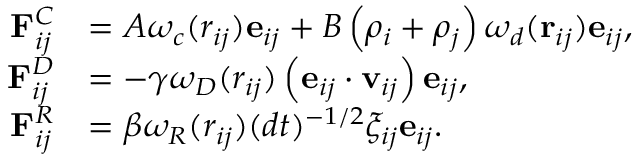Convert formula to latex. <formula><loc_0><loc_0><loc_500><loc_500>\begin{array} { r l } { F _ { i j } ^ { C } } & { = A \omega _ { c } ( r _ { i j } ) e _ { i j } + B \left ( \rho _ { i } + \rho _ { j } \right ) \omega _ { d } ( r _ { i j } ) e _ { i j } , } \\ { F _ { i j } ^ { D } } & { = - \gamma \omega _ { D } ( r _ { i j } ) \left ( e _ { i j } \cdot v _ { i j } \right ) e _ { i j } , } \\ { F _ { i j } ^ { R } } & { = \beta \omega _ { R } ( r _ { i j } ) ( d t ) ^ { - 1 / 2 } \xi _ { i j } e _ { i j } . } \end{array}</formula> 